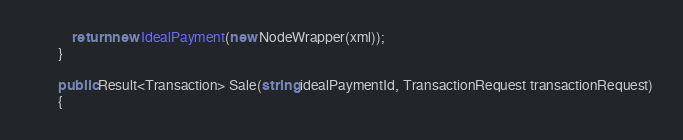Convert code to text. <code><loc_0><loc_0><loc_500><loc_500><_C#_>            return new IdealPayment(new NodeWrapper(xml));
        }

        public Result<Transaction> Sale(string idealPaymentId, TransactionRequest transactionRequest)
        {</code> 